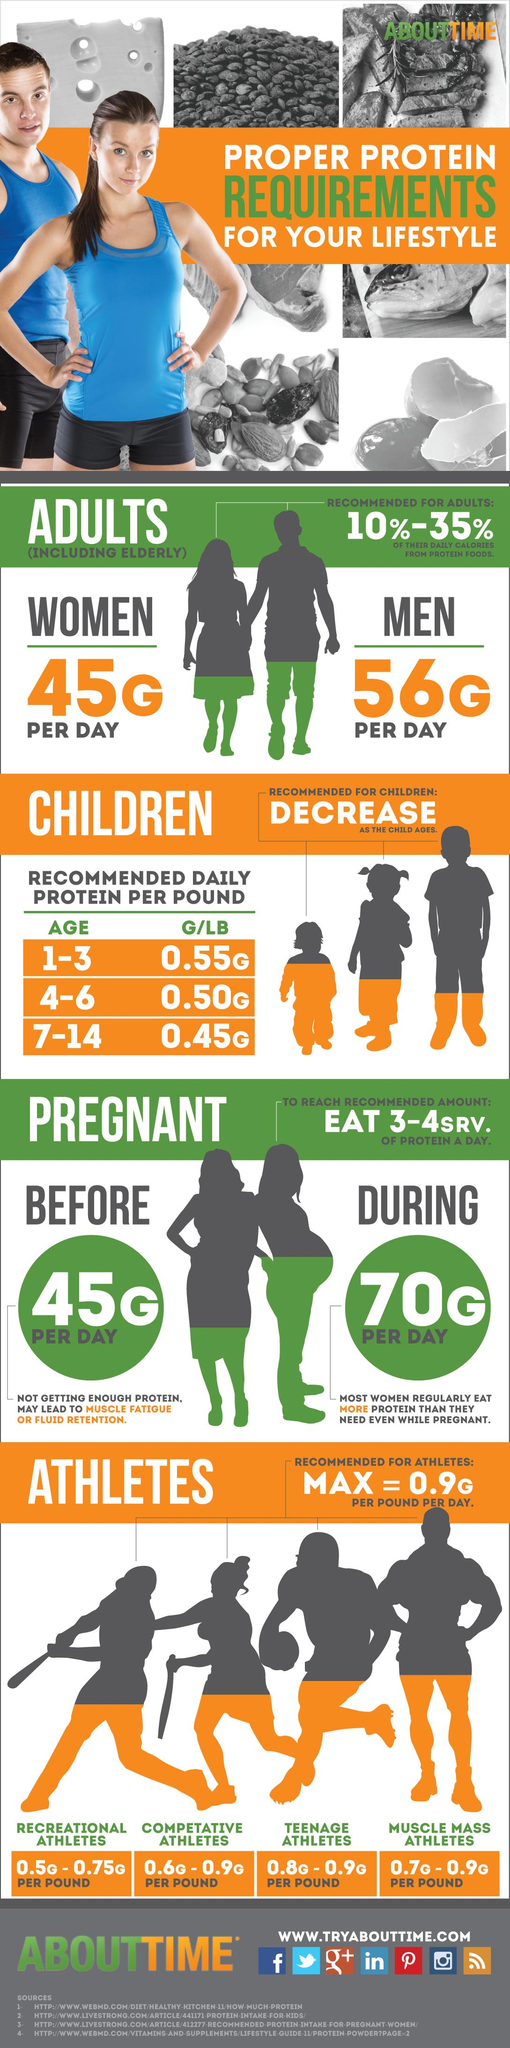Draw attention to some important aspects in this diagram. The recommended amount of protein per pound for children aged 7-14 years is 0.45 grams. According to research, the age group of children between 1 and 3 requires the most protein to support their rapid growth and development. The minimum recommended daily protein intake for recreational athletes is 0.5 grams per pound of body weight. It is recommended that women consume approximately 45 grams of protein per day. The recommended amount of protein intake for a woman before getting pregnant is 45 grams per day. 